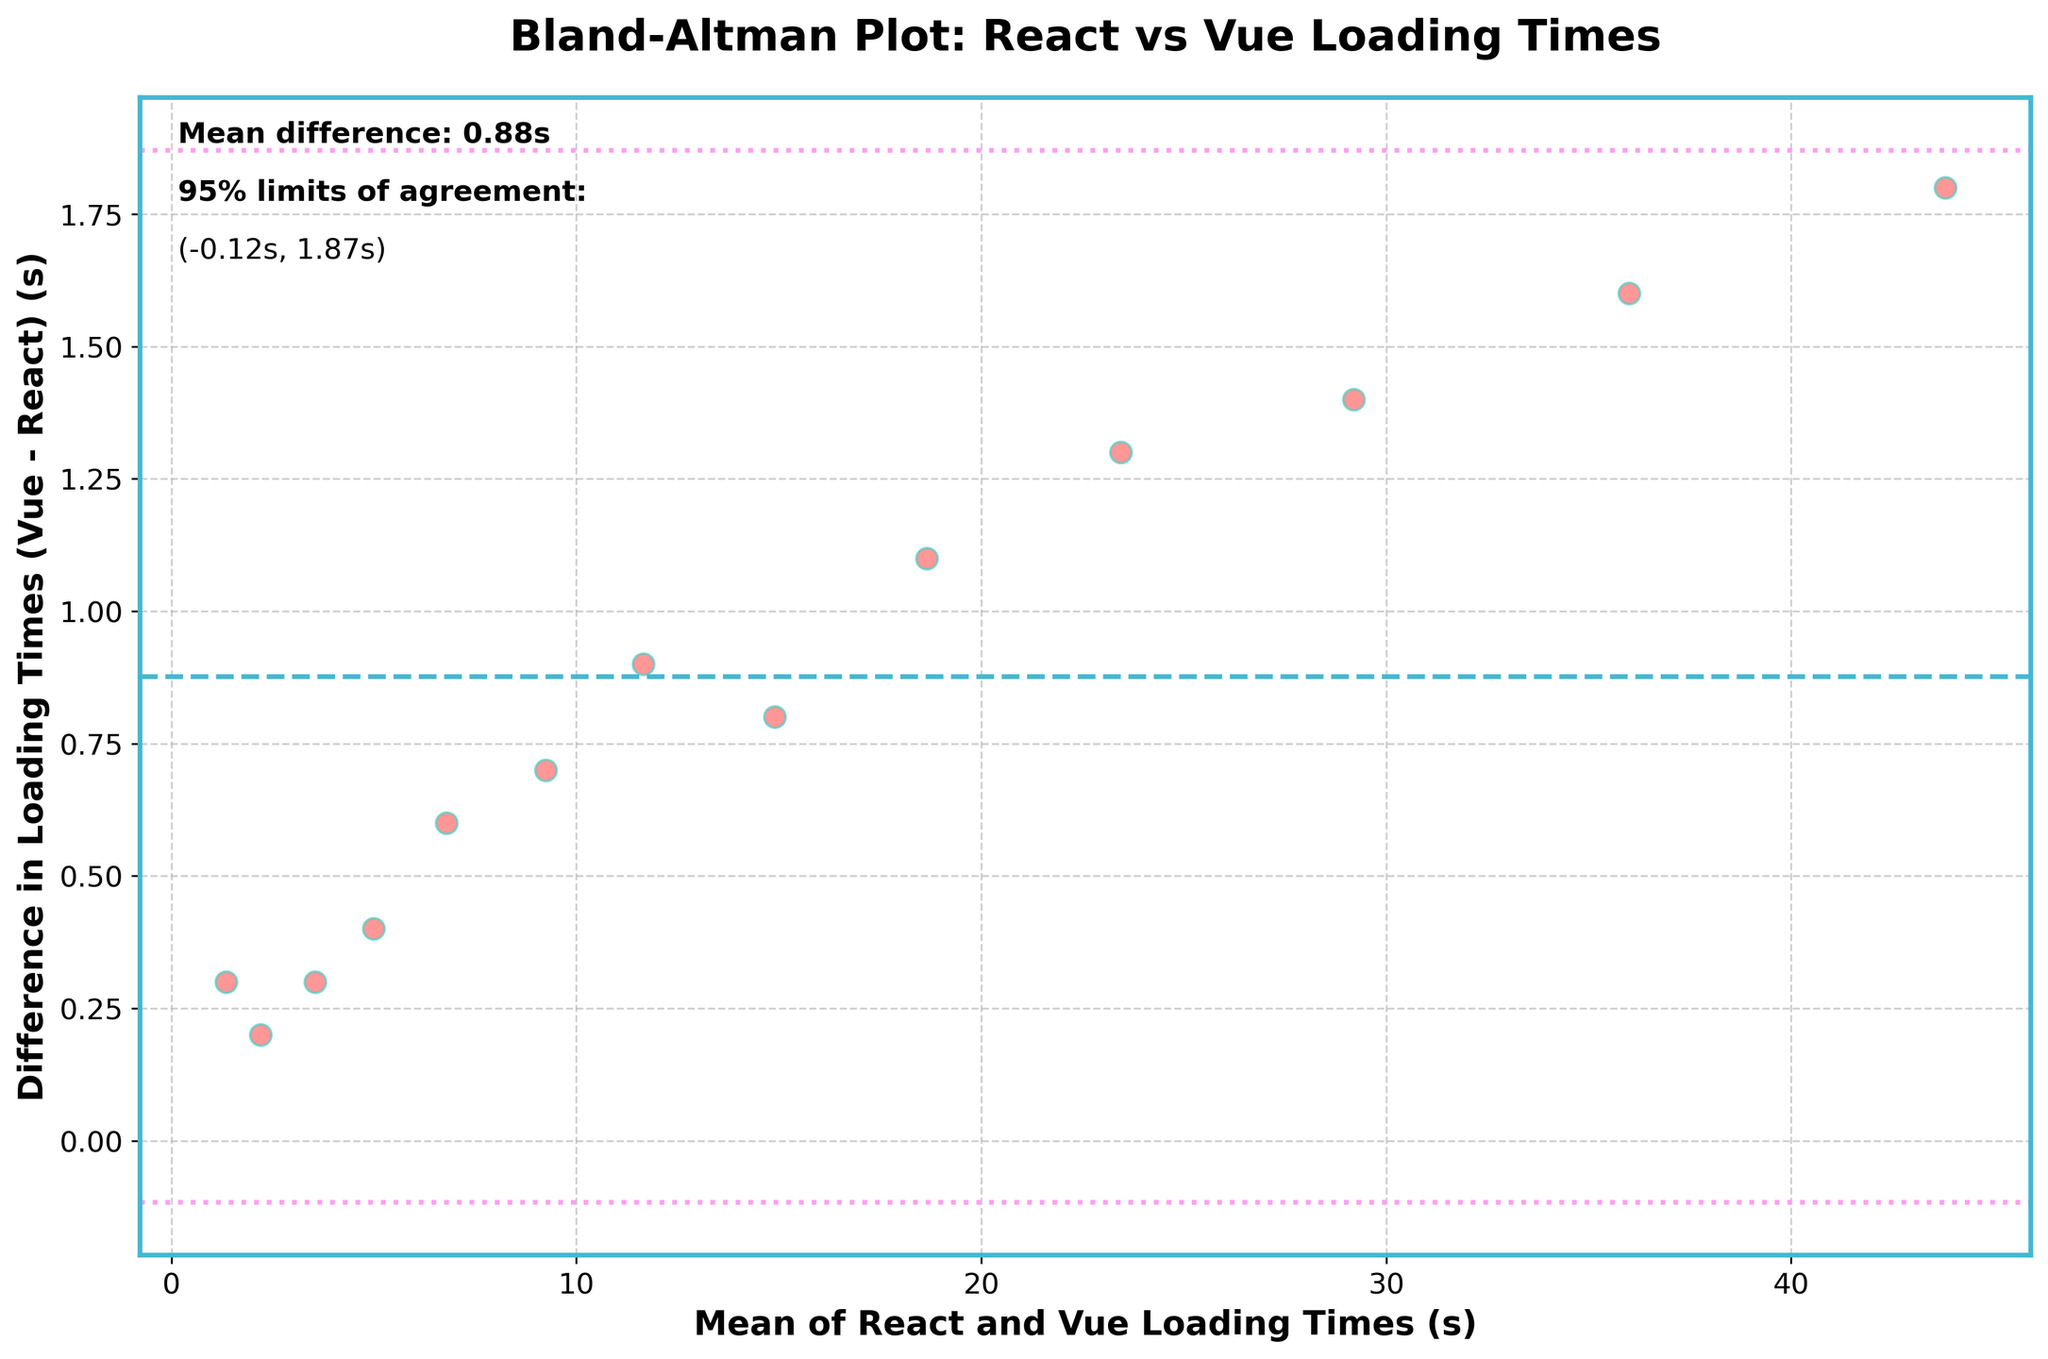What's the title of the plot? The title of the plot is usually displayed at the top of the figure in a larger or bolder font size than other text elements. In this case, it reads "Bland-Altman Plot: React vs Vue Loading Times".
Answer: Bland-Altman Plot: React vs Vue Loading Times How many data points are shown in the scatter plot? To determine the number of data points, count the individual dots displayed in the plot. Each dot represents a data point based on the loading times of React and Vue frameworks for different website sizes.
Answer: 13 What color are the scatter plot dots? The color of the dots on the scatter plot can be identified by looking at the visual appearance of the dots. In this plot, the dots are colored in a shade of red.
Answer: Red What do the horizontal lines on the plot represent? There are three horizontal lines on the Bland-Altman plot. The middle line represents the mean difference between the two sets of loading times. The lines above and below it represent the limits of agreement (mean difference ± 1.96 times the standard deviation).
Answer: Mean difference and limits of agreement What are the values of the 95% limits of agreement? To find the 95% limits of agreement, identify the values where the dotted lines (above and below the mean difference line) intersect the y-axis. In this plot, these values are labeled in the text annotations.
Answer: (-1.30s, 1.42s) What does the mean difference indicate about the average loading times of React and Vue? The mean difference indicates the average discrepancy between Vue and React loading times across various website sizes. If the mean difference is positive, it means that, on average, Vue has higher loading times compared to React. For this plot, the mean difference is 0.06 seconds, suggesting Vue's loading times are slightly higher on average.
Answer: Vue times are slightly higher Which data point has the smallest mean loading time? To find the data point with the smallest mean loading time, look at the x-axis (Mean Loading Time), and identify the leftmost dot. This corresponds to the smallest mean value of combined React and Vue loading times.
Answer: 1.35 seconds (Small website) Which data point shows the largest difference in loading times between React and Vue? To find the data point with the largest difference in loading times, look for the dot that is furthest away from the mean difference line (horizontal center line), either above or below.
Answer: For a website size of 200, the difference is 0.6 seconds Is there any trend in the differences related to the size of the websites? A trend can be inferred by observing the distribution of the dots along the y-axis. If the differences are consistently increasing or decreasing with the mean loading times, it would suggest a trend. In this plot, the differences do not show such a trend, suggesting they vary independently of website size.
Answer: No clear trend 